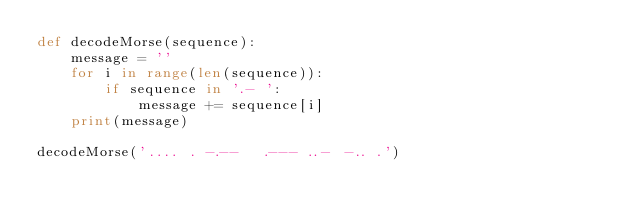Convert code to text. <code><loc_0><loc_0><loc_500><loc_500><_Python_>def decodeMorse(sequence):
    message = ''
    for i in range(len(sequence)):
        if sequence in '.- ':
            message += sequence[i]
    print(message)

decodeMorse('.... . -.--   .--- ..- -.. .')</code> 